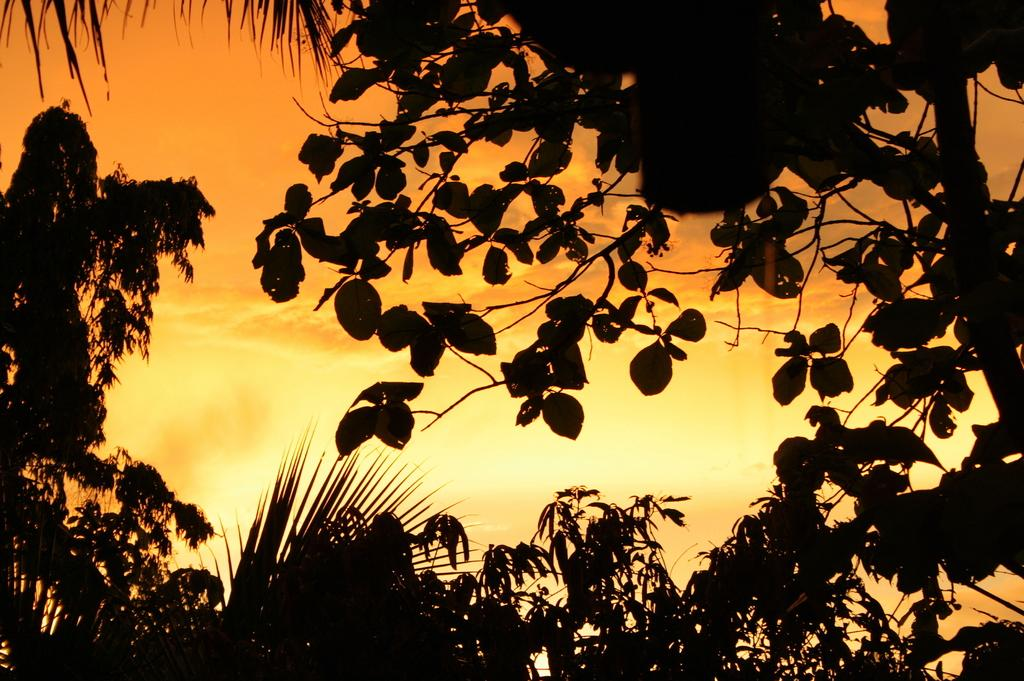What type of vegetation can be seen in the image? There are trees in the image. What is visible in the background of the image? The sky is visible in the image. What can be observed in the sky? Clouds are present in the sky. What type of force is being exerted on the wire in the image? There is no wire present in the image, so it is not possible to determine if any force is being exerted on it. 